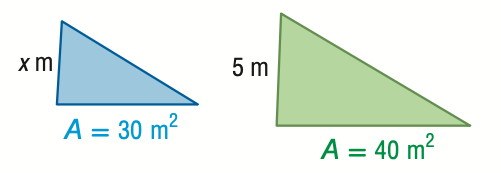Answer the mathemtical geometry problem and directly provide the correct option letter.
Question: For the pair of similar figures, use the given areas to find x.
Choices: A: 3.7 B: 4.3 C: 5.8 D: 6.7 B 